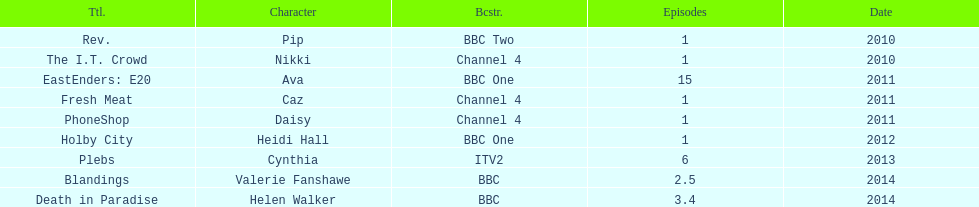What was the previous role this actress played before playing cynthia in plebs? Heidi Hall. 